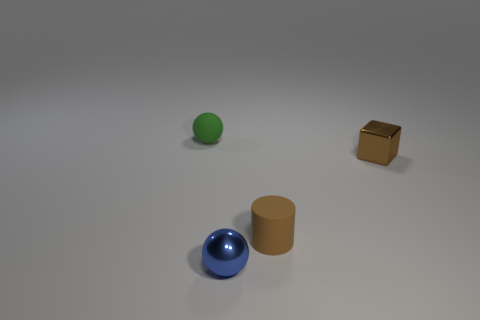Add 3 metal objects. How many objects exist? 7 Add 1 brown things. How many brown things are left? 3 Add 2 large blocks. How many large blocks exist? 2 Subtract 0 blue blocks. How many objects are left? 4 Subtract all blue balls. Subtract all cyan cylinders. How many balls are left? 1 Subtract all cylinders. Subtract all tiny green things. How many objects are left? 2 